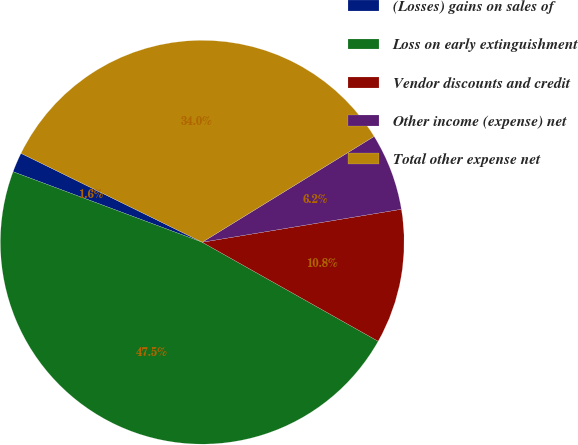<chart> <loc_0><loc_0><loc_500><loc_500><pie_chart><fcel>(Losses) gains on sales of<fcel>Loss on early extinguishment<fcel>Vendor discounts and credit<fcel>Other income (expense) net<fcel>Total other expense net<nl><fcel>1.58%<fcel>47.52%<fcel>10.77%<fcel>6.17%<fcel>33.96%<nl></chart> 